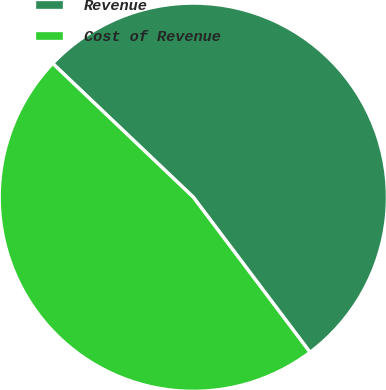Convert chart to OTSL. <chart><loc_0><loc_0><loc_500><loc_500><pie_chart><fcel>Revenue<fcel>Cost of Revenue<nl><fcel>52.63%<fcel>47.37%<nl></chart> 